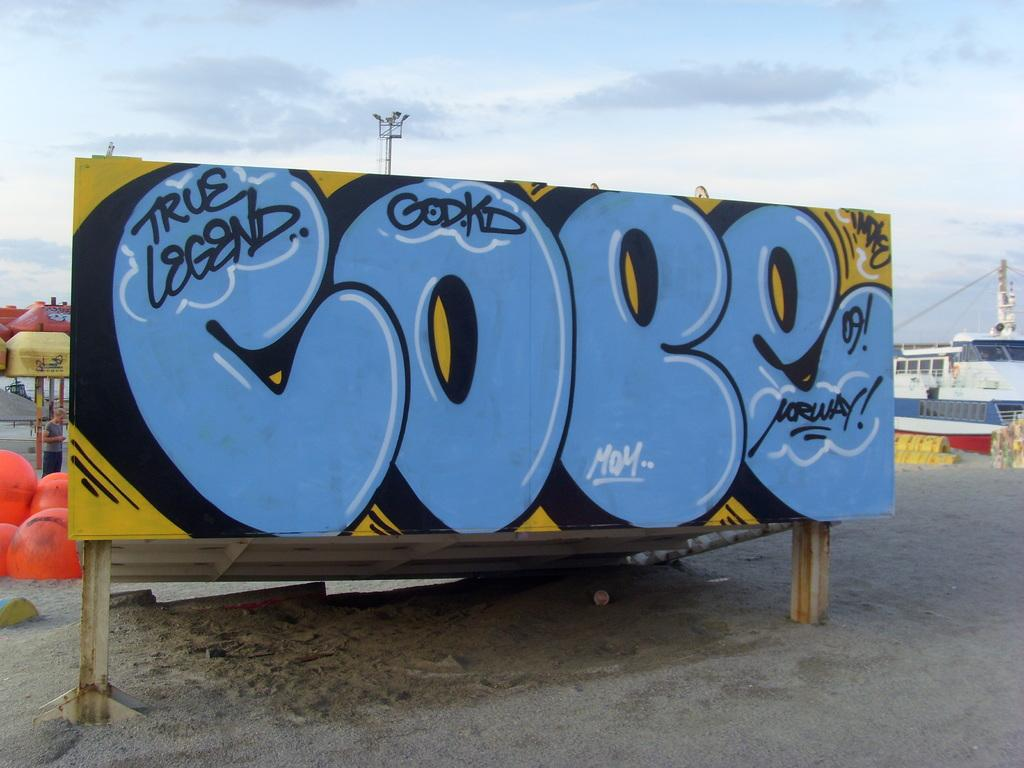<image>
Present a compact description of the photo's key features. Graffiti written on a large sign stating true legend. 